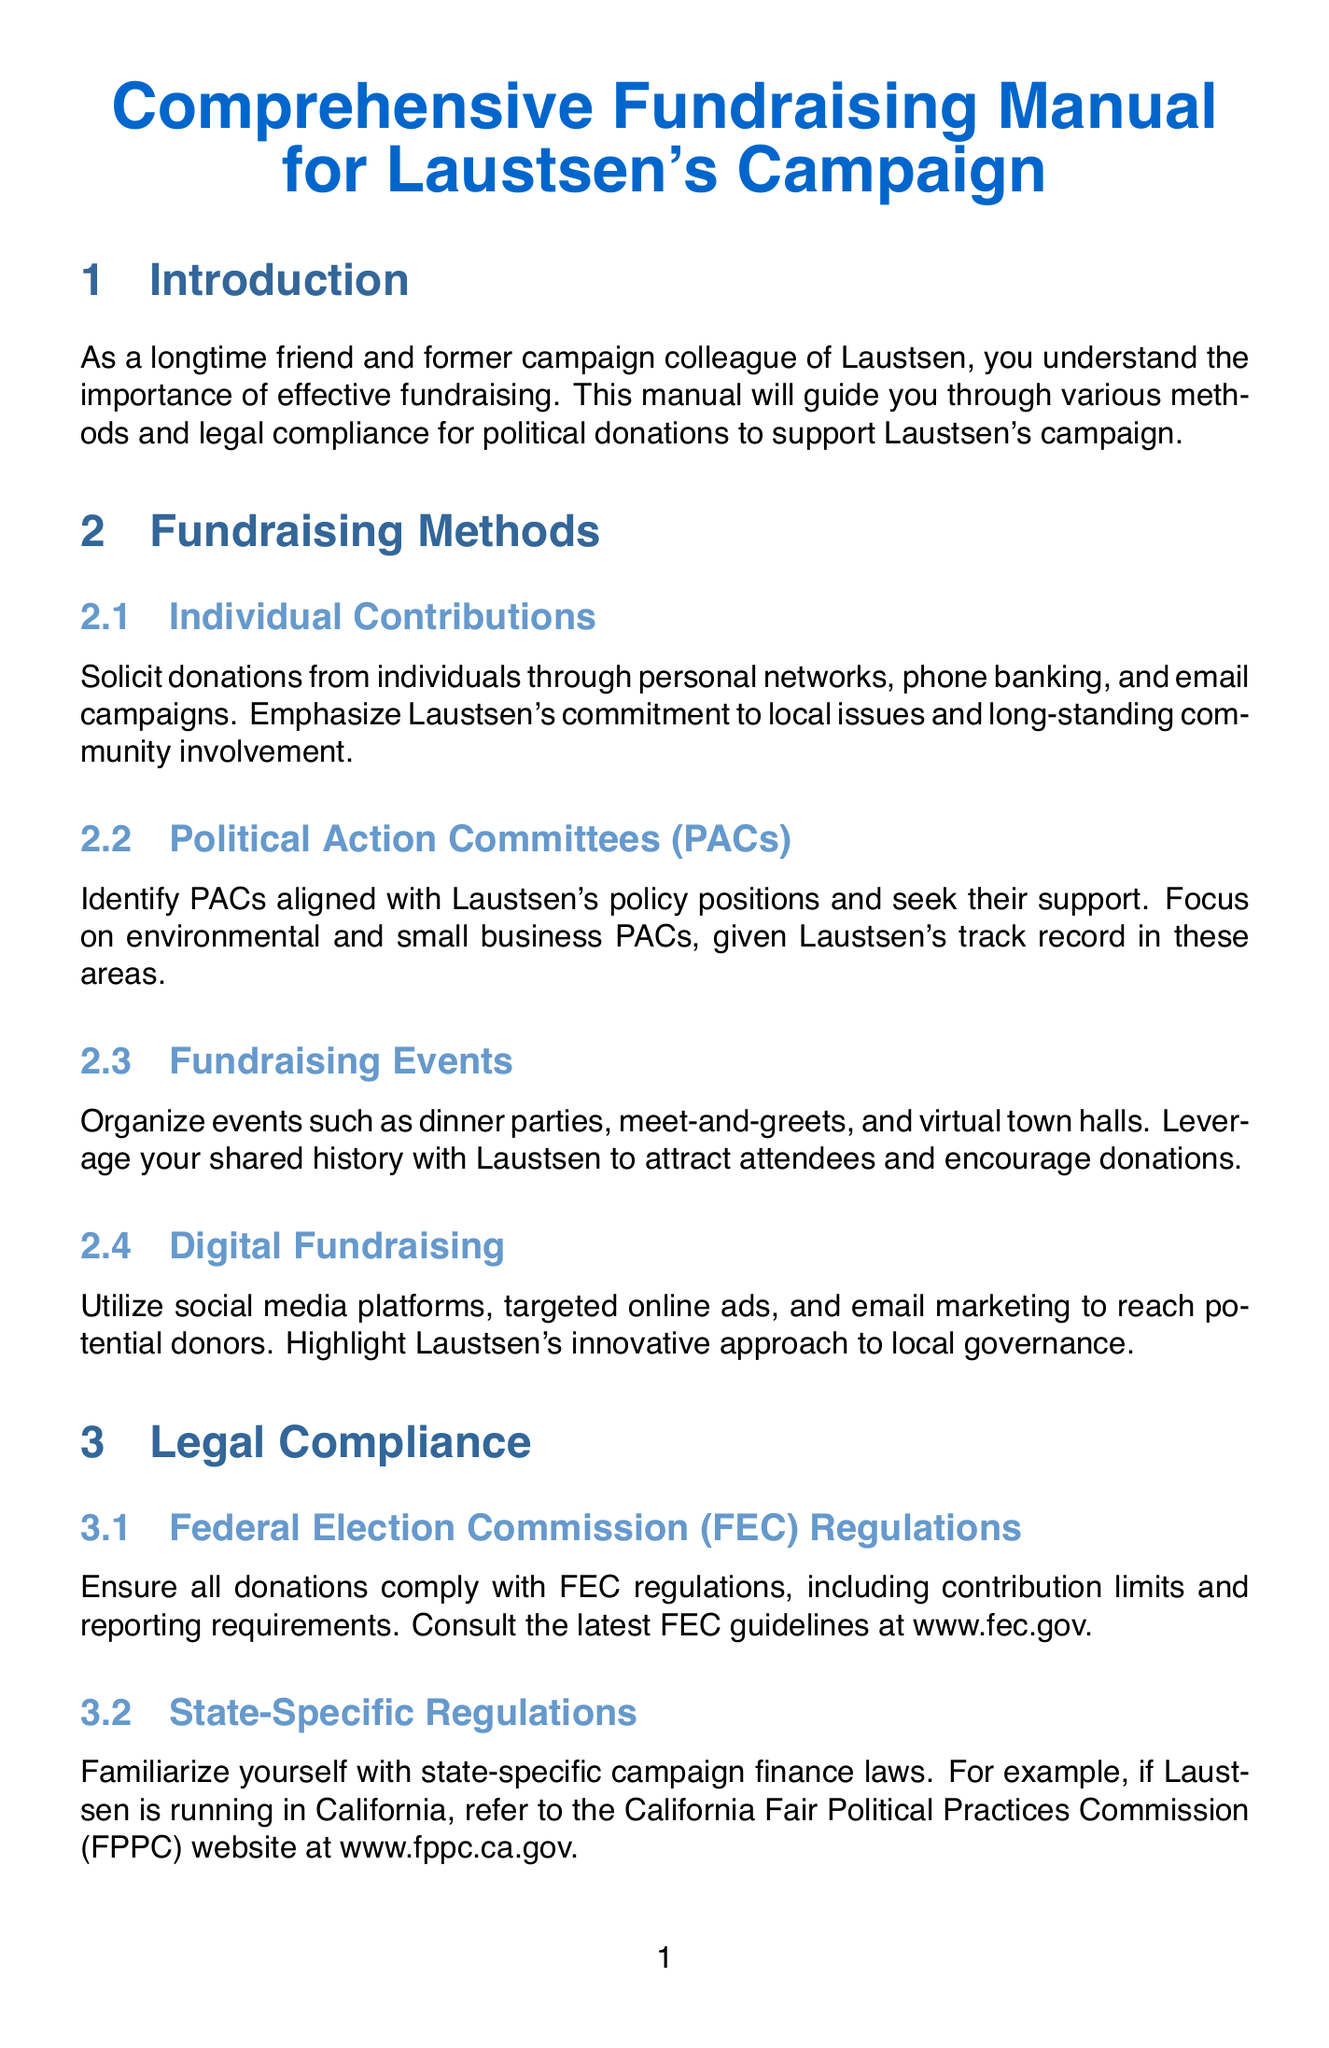What is the title of the manual? The title of the manual is presented at the beginning of the document.
Answer: Comprehensive Fundraising Manual for Laustsen's Campaign How many fundraising methods are outlined in the manual? The manual lists a section on Fundraising Methods that includes individual contributions, PACs, fundraising events, and digital fundraising.
Answer: Four Who should be recommended as the compliance officer? The manual suggests a specific colleague with expertise in campaign finance laws for the finance team.
Answer: Sarah Chen What federal body regulates political donations? The manual discusses legal compliance, specifically regarding donations regulated by a specific federal agency.
Answer: Federal Election Commission (FEC) What types of events are mentioned as fundraising events? The manual provides examples of fundraising events that can be organized to support Laustsen's campaign.
Answer: Dinner parties, meet-and-greets, virtual town halls What should be done with foreign contributions? The legal compliance section of the manual emphasizes actions regarding contributions from foreign sources.
Answer: Prohibited What is highlighted as a necessary feature of fundraising software? The manual mentions a specific requirement for using fundraising software effectively.
Answer: Streamline donation processing What ethical principle is emphasized in fundraising practices? One section of the manual discusses a core value that should guide fundraising activities.
Answer: Transparency 